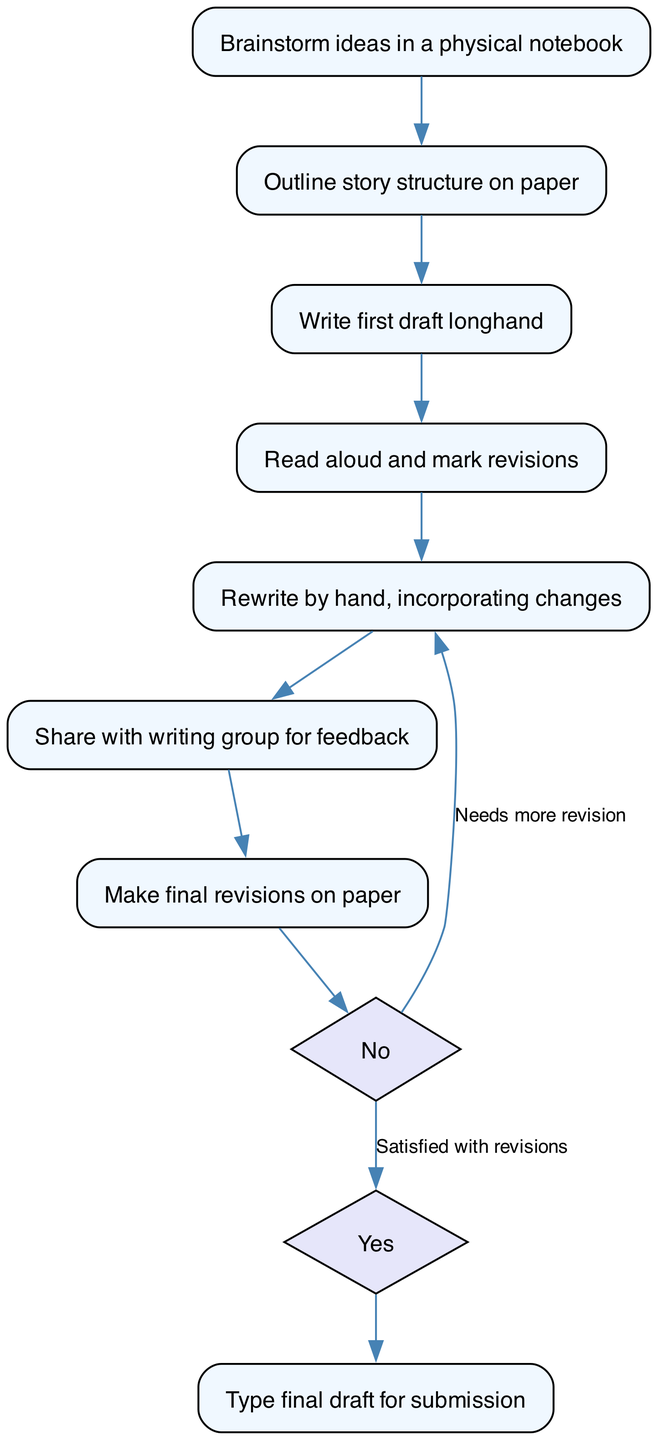What is the first step in the writing process? The first step according to the diagram is "Brainstorm ideas in a physical notebook." This can be found at the top of the flow chart, indicating it initiates the process.
Answer: Brainstorm ideas in a physical notebook How many main steps are there in the writing process? By counting the nodes representing main steps (excluding decision nodes), we find eight key steps: brainstorming, outlining, drafting, reading, rewriting, sharing feedback, revising, and typing.
Answer: Eight Which step involves marking revisions? The step that involves marking revisions is "Read aloud and mark revisions." This is identified directly from the flow line connecting it after the first draft step.
Answer: Read aloud and mark revisions What happens if the writer is not satisfied with revisions? If the writer is not satisfied with revisions, the flowchart indicates that they return to the "Rewrite by hand, incorporating changes" step. This shows a cycle that allows for further refinement.
Answer: Rewrite by hand, incorporating changes What is the last step of the writing process? The last step in the process, before submission, is "Type final draft for submission," indicating the transition from handwritten work to a digital format.
Answer: Type final draft for submission Which step allows for external feedback? The step that allows for external feedback is "Share with writing group for feedback." This is explicitly mentioned as a part of the process after rewriting, making it a collaborative element.
Answer: Share with writing group for feedback What decision point occurs after making final revisions? The decision point after making final revisions asks whether the writer is satisfied with the revisions. The diagram shows two paths diverging from this decision node based on the writer's satisfaction.
Answer: Satisfied with revisions How do decision nodes influence the writing process? Decision nodes introduce a choice between continuing with revisions or moving to the final draft. They influence the process by determining whether to repeat previous steps or proceed forward based on satisfaction.
Answer: They introduce choices that alter the path 